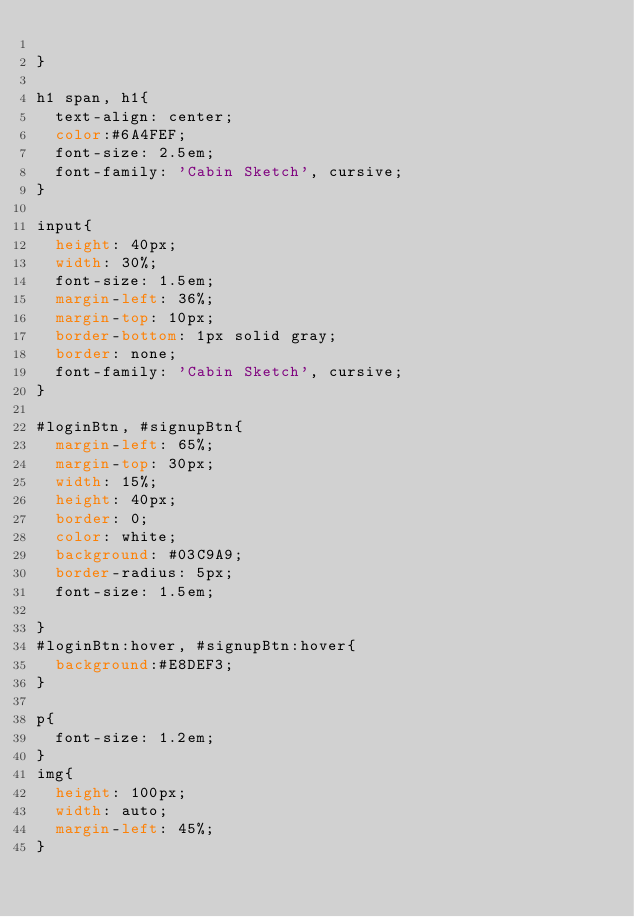Convert code to text. <code><loc_0><loc_0><loc_500><loc_500><_CSS_>
}

h1 span, h1{
  text-align: center;
  color:#6A4FEF;
  font-size: 2.5em;
  font-family: 'Cabin Sketch', cursive;
}

input{
  height: 40px;
  width: 30%;
  font-size: 1.5em;
  margin-left: 36%;
  margin-top: 10px;
  border-bottom: 1px solid gray;
  border: none;
  font-family: 'Cabin Sketch', cursive;
}

#loginBtn, #signupBtn{
  margin-left: 65%;
  margin-top: 30px;
  width: 15%;
  height: 40px;
  border: 0;
  color: white;
  background: #03C9A9;
  border-radius: 5px;
  font-size: 1.5em;

}
#loginBtn:hover, #signupBtn:hover{
  background:#E8DEF3;
}

p{
  font-size: 1.2em;
}
img{
  height: 100px;
  width: auto;
  margin-left: 45%;
}
</code> 